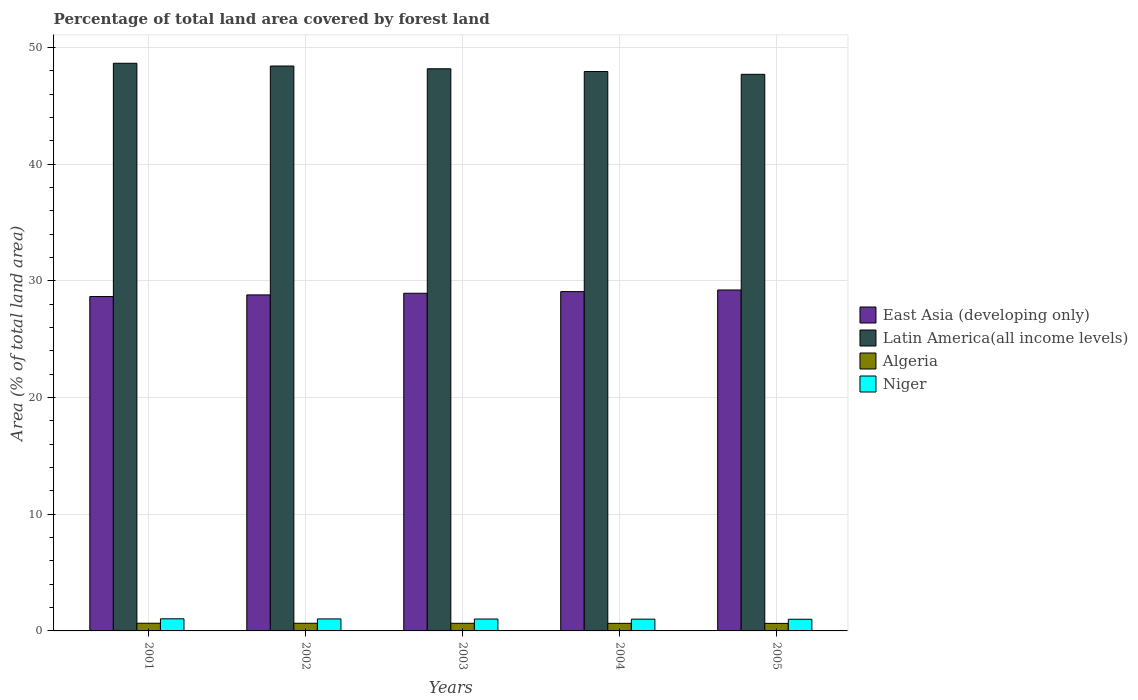How many different coloured bars are there?
Your response must be concise. 4. Are the number of bars per tick equal to the number of legend labels?
Offer a terse response. Yes. What is the label of the 1st group of bars from the left?
Make the answer very short. 2001. In how many cases, is the number of bars for a given year not equal to the number of legend labels?
Ensure brevity in your answer.  0. What is the percentage of forest land in East Asia (developing only) in 2001?
Ensure brevity in your answer.  28.65. Across all years, what is the maximum percentage of forest land in East Asia (developing only)?
Your answer should be very brief. 29.22. Across all years, what is the minimum percentage of forest land in Niger?
Offer a very short reply. 1. In which year was the percentage of forest land in Latin America(all income levels) minimum?
Provide a succinct answer. 2005. What is the total percentage of forest land in East Asia (developing only) in the graph?
Provide a succinct answer. 144.68. What is the difference between the percentage of forest land in Latin America(all income levels) in 2003 and that in 2004?
Your response must be concise. 0.24. What is the difference between the percentage of forest land in Latin America(all income levels) in 2005 and the percentage of forest land in East Asia (developing only) in 2004?
Your answer should be very brief. 18.62. What is the average percentage of forest land in Niger per year?
Give a very brief answer. 1.02. In the year 2004, what is the difference between the percentage of forest land in East Asia (developing only) and percentage of forest land in Algeria?
Keep it short and to the point. 28.43. In how many years, is the percentage of forest land in Niger greater than 10 %?
Offer a terse response. 0. What is the ratio of the percentage of forest land in Niger in 2001 to that in 2002?
Your response must be concise. 1.01. Is the percentage of forest land in Niger in 2001 less than that in 2003?
Offer a very short reply. No. Is the difference between the percentage of forest land in East Asia (developing only) in 2001 and 2004 greater than the difference between the percentage of forest land in Algeria in 2001 and 2004?
Your answer should be compact. No. What is the difference between the highest and the second highest percentage of forest land in Niger?
Keep it short and to the point. 0.01. What is the difference between the highest and the lowest percentage of forest land in Niger?
Provide a succinct answer. 0.04. What does the 1st bar from the left in 2004 represents?
Keep it short and to the point. East Asia (developing only). What does the 1st bar from the right in 2001 represents?
Provide a succinct answer. Niger. How many bars are there?
Make the answer very short. 20. How many years are there in the graph?
Give a very brief answer. 5. What is the difference between two consecutive major ticks on the Y-axis?
Ensure brevity in your answer.  10. Are the values on the major ticks of Y-axis written in scientific E-notation?
Your answer should be very brief. No. Does the graph contain any zero values?
Provide a short and direct response. No. Does the graph contain grids?
Make the answer very short. Yes. Where does the legend appear in the graph?
Your answer should be very brief. Center right. How many legend labels are there?
Your response must be concise. 4. What is the title of the graph?
Keep it short and to the point. Percentage of total land area covered by forest land. What is the label or title of the Y-axis?
Provide a short and direct response. Area (% of total land area). What is the Area (% of total land area) of East Asia (developing only) in 2001?
Provide a succinct answer. 28.65. What is the Area (% of total land area) in Latin America(all income levels) in 2001?
Your answer should be compact. 48.65. What is the Area (% of total land area) in Algeria in 2001?
Keep it short and to the point. 0.66. What is the Area (% of total land area) in Niger in 2001?
Your response must be concise. 1.04. What is the Area (% of total land area) in East Asia (developing only) in 2002?
Provide a succinct answer. 28.8. What is the Area (% of total land area) in Latin America(all income levels) in 2002?
Offer a terse response. 48.41. What is the Area (% of total land area) in Algeria in 2002?
Offer a terse response. 0.66. What is the Area (% of total land area) in Niger in 2002?
Ensure brevity in your answer.  1.03. What is the Area (% of total land area) in East Asia (developing only) in 2003?
Offer a very short reply. 28.94. What is the Area (% of total land area) in Latin America(all income levels) in 2003?
Give a very brief answer. 48.17. What is the Area (% of total land area) of Algeria in 2003?
Offer a very short reply. 0.65. What is the Area (% of total land area) of Niger in 2003?
Give a very brief answer. 1.02. What is the Area (% of total land area) of East Asia (developing only) in 2004?
Give a very brief answer. 29.08. What is the Area (% of total land area) of Latin America(all income levels) in 2004?
Your response must be concise. 47.94. What is the Area (% of total land area) in Algeria in 2004?
Provide a succinct answer. 0.65. What is the Area (% of total land area) of Niger in 2004?
Your answer should be very brief. 1.01. What is the Area (% of total land area) in East Asia (developing only) in 2005?
Make the answer very short. 29.22. What is the Area (% of total land area) in Latin America(all income levels) in 2005?
Ensure brevity in your answer.  47.7. What is the Area (% of total land area) in Algeria in 2005?
Offer a very short reply. 0.64. What is the Area (% of total land area) of Niger in 2005?
Offer a very short reply. 1. Across all years, what is the maximum Area (% of total land area) of East Asia (developing only)?
Provide a succinct answer. 29.22. Across all years, what is the maximum Area (% of total land area) of Latin America(all income levels)?
Your response must be concise. 48.65. Across all years, what is the maximum Area (% of total land area) in Algeria?
Offer a terse response. 0.66. Across all years, what is the maximum Area (% of total land area) in Niger?
Ensure brevity in your answer.  1.04. Across all years, what is the minimum Area (% of total land area) in East Asia (developing only)?
Give a very brief answer. 28.65. Across all years, what is the minimum Area (% of total land area) of Latin America(all income levels)?
Keep it short and to the point. 47.7. Across all years, what is the minimum Area (% of total land area) of Algeria?
Provide a short and direct response. 0.64. Across all years, what is the minimum Area (% of total land area) of Niger?
Ensure brevity in your answer.  1. What is the total Area (% of total land area) of East Asia (developing only) in the graph?
Your answer should be compact. 144.68. What is the total Area (% of total land area) of Latin America(all income levels) in the graph?
Ensure brevity in your answer.  240.86. What is the total Area (% of total land area) in Algeria in the graph?
Keep it short and to the point. 3.26. What is the total Area (% of total land area) of Niger in the graph?
Keep it short and to the point. 5.1. What is the difference between the Area (% of total land area) in East Asia (developing only) in 2001 and that in 2002?
Ensure brevity in your answer.  -0.14. What is the difference between the Area (% of total land area) of Latin America(all income levels) in 2001 and that in 2002?
Make the answer very short. 0.23. What is the difference between the Area (% of total land area) of Algeria in 2001 and that in 2002?
Your answer should be very brief. 0. What is the difference between the Area (% of total land area) in Niger in 2001 and that in 2002?
Your response must be concise. 0.01. What is the difference between the Area (% of total land area) of East Asia (developing only) in 2001 and that in 2003?
Give a very brief answer. -0.28. What is the difference between the Area (% of total land area) of Latin America(all income levels) in 2001 and that in 2003?
Ensure brevity in your answer.  0.47. What is the difference between the Area (% of total land area) of Algeria in 2001 and that in 2003?
Offer a terse response. 0.01. What is the difference between the Area (% of total land area) of Niger in 2001 and that in 2003?
Make the answer very short. 0.02. What is the difference between the Area (% of total land area) in East Asia (developing only) in 2001 and that in 2004?
Ensure brevity in your answer.  -0.42. What is the difference between the Area (% of total land area) of Latin America(all income levels) in 2001 and that in 2004?
Offer a terse response. 0.71. What is the difference between the Area (% of total land area) in Algeria in 2001 and that in 2004?
Keep it short and to the point. 0.01. What is the difference between the Area (% of total land area) in Niger in 2001 and that in 2004?
Provide a succinct answer. 0.03. What is the difference between the Area (% of total land area) in East Asia (developing only) in 2001 and that in 2005?
Your answer should be compact. -0.56. What is the difference between the Area (% of total land area) in Latin America(all income levels) in 2001 and that in 2005?
Make the answer very short. 0.95. What is the difference between the Area (% of total land area) in Algeria in 2001 and that in 2005?
Provide a short and direct response. 0.01. What is the difference between the Area (% of total land area) in Niger in 2001 and that in 2005?
Keep it short and to the point. 0.04. What is the difference between the Area (% of total land area) of East Asia (developing only) in 2002 and that in 2003?
Your answer should be compact. -0.14. What is the difference between the Area (% of total land area) in Latin America(all income levels) in 2002 and that in 2003?
Make the answer very short. 0.24. What is the difference between the Area (% of total land area) of Algeria in 2002 and that in 2003?
Provide a succinct answer. 0. What is the difference between the Area (% of total land area) of Niger in 2002 and that in 2003?
Provide a short and direct response. 0.01. What is the difference between the Area (% of total land area) of East Asia (developing only) in 2002 and that in 2004?
Ensure brevity in your answer.  -0.28. What is the difference between the Area (% of total land area) in Latin America(all income levels) in 2002 and that in 2004?
Your answer should be compact. 0.47. What is the difference between the Area (% of total land area) in Algeria in 2002 and that in 2004?
Provide a short and direct response. 0.01. What is the difference between the Area (% of total land area) of Niger in 2002 and that in 2004?
Keep it short and to the point. 0.02. What is the difference between the Area (% of total land area) in East Asia (developing only) in 2002 and that in 2005?
Your answer should be very brief. -0.42. What is the difference between the Area (% of total land area) of Latin America(all income levels) in 2002 and that in 2005?
Your response must be concise. 0.71. What is the difference between the Area (% of total land area) in Algeria in 2002 and that in 2005?
Give a very brief answer. 0.01. What is the difference between the Area (% of total land area) in Niger in 2002 and that in 2005?
Provide a succinct answer. 0.03. What is the difference between the Area (% of total land area) in East Asia (developing only) in 2003 and that in 2004?
Make the answer very short. -0.14. What is the difference between the Area (% of total land area) of Latin America(all income levels) in 2003 and that in 2004?
Ensure brevity in your answer.  0.24. What is the difference between the Area (% of total land area) of Algeria in 2003 and that in 2004?
Your answer should be compact. 0. What is the difference between the Area (% of total land area) of Niger in 2003 and that in 2004?
Ensure brevity in your answer.  0.01. What is the difference between the Area (% of total land area) of East Asia (developing only) in 2003 and that in 2005?
Make the answer very short. -0.28. What is the difference between the Area (% of total land area) of Latin America(all income levels) in 2003 and that in 2005?
Give a very brief answer. 0.47. What is the difference between the Area (% of total land area) in Algeria in 2003 and that in 2005?
Your answer should be compact. 0.01. What is the difference between the Area (% of total land area) in Niger in 2003 and that in 2005?
Your answer should be very brief. 0.02. What is the difference between the Area (% of total land area) of East Asia (developing only) in 2004 and that in 2005?
Offer a very short reply. -0.14. What is the difference between the Area (% of total land area) of Latin America(all income levels) in 2004 and that in 2005?
Your answer should be very brief. 0.24. What is the difference between the Area (% of total land area) in Algeria in 2004 and that in 2005?
Provide a short and direct response. 0. What is the difference between the Area (% of total land area) in Niger in 2004 and that in 2005?
Your response must be concise. 0.01. What is the difference between the Area (% of total land area) in East Asia (developing only) in 2001 and the Area (% of total land area) in Latin America(all income levels) in 2002?
Ensure brevity in your answer.  -19.76. What is the difference between the Area (% of total land area) of East Asia (developing only) in 2001 and the Area (% of total land area) of Algeria in 2002?
Your answer should be compact. 28. What is the difference between the Area (% of total land area) of East Asia (developing only) in 2001 and the Area (% of total land area) of Niger in 2002?
Give a very brief answer. 27.63. What is the difference between the Area (% of total land area) in Latin America(all income levels) in 2001 and the Area (% of total land area) in Algeria in 2002?
Keep it short and to the point. 47.99. What is the difference between the Area (% of total land area) of Latin America(all income levels) in 2001 and the Area (% of total land area) of Niger in 2002?
Provide a short and direct response. 47.62. What is the difference between the Area (% of total land area) of Algeria in 2001 and the Area (% of total land area) of Niger in 2002?
Your answer should be very brief. -0.37. What is the difference between the Area (% of total land area) of East Asia (developing only) in 2001 and the Area (% of total land area) of Latin America(all income levels) in 2003?
Ensure brevity in your answer.  -19.52. What is the difference between the Area (% of total land area) of East Asia (developing only) in 2001 and the Area (% of total land area) of Algeria in 2003?
Offer a very short reply. 28. What is the difference between the Area (% of total land area) in East Asia (developing only) in 2001 and the Area (% of total land area) in Niger in 2003?
Keep it short and to the point. 27.64. What is the difference between the Area (% of total land area) of Latin America(all income levels) in 2001 and the Area (% of total land area) of Algeria in 2003?
Your response must be concise. 47.99. What is the difference between the Area (% of total land area) of Latin America(all income levels) in 2001 and the Area (% of total land area) of Niger in 2003?
Keep it short and to the point. 47.63. What is the difference between the Area (% of total land area) of Algeria in 2001 and the Area (% of total land area) of Niger in 2003?
Your response must be concise. -0.36. What is the difference between the Area (% of total land area) of East Asia (developing only) in 2001 and the Area (% of total land area) of Latin America(all income levels) in 2004?
Your answer should be compact. -19.28. What is the difference between the Area (% of total land area) in East Asia (developing only) in 2001 and the Area (% of total land area) in Algeria in 2004?
Your response must be concise. 28.01. What is the difference between the Area (% of total land area) in East Asia (developing only) in 2001 and the Area (% of total land area) in Niger in 2004?
Offer a terse response. 27.65. What is the difference between the Area (% of total land area) of Latin America(all income levels) in 2001 and the Area (% of total land area) of Algeria in 2004?
Your answer should be compact. 48. What is the difference between the Area (% of total land area) of Latin America(all income levels) in 2001 and the Area (% of total land area) of Niger in 2004?
Your answer should be compact. 47.64. What is the difference between the Area (% of total land area) of Algeria in 2001 and the Area (% of total land area) of Niger in 2004?
Your answer should be compact. -0.35. What is the difference between the Area (% of total land area) of East Asia (developing only) in 2001 and the Area (% of total land area) of Latin America(all income levels) in 2005?
Your response must be concise. -19.04. What is the difference between the Area (% of total land area) of East Asia (developing only) in 2001 and the Area (% of total land area) of Algeria in 2005?
Offer a terse response. 28.01. What is the difference between the Area (% of total land area) of East Asia (developing only) in 2001 and the Area (% of total land area) of Niger in 2005?
Ensure brevity in your answer.  27.66. What is the difference between the Area (% of total land area) in Latin America(all income levels) in 2001 and the Area (% of total land area) in Algeria in 2005?
Make the answer very short. 48. What is the difference between the Area (% of total land area) of Latin America(all income levels) in 2001 and the Area (% of total land area) of Niger in 2005?
Offer a terse response. 47.65. What is the difference between the Area (% of total land area) of Algeria in 2001 and the Area (% of total land area) of Niger in 2005?
Provide a succinct answer. -0.34. What is the difference between the Area (% of total land area) in East Asia (developing only) in 2002 and the Area (% of total land area) in Latin America(all income levels) in 2003?
Keep it short and to the point. -19.38. What is the difference between the Area (% of total land area) of East Asia (developing only) in 2002 and the Area (% of total land area) of Algeria in 2003?
Your response must be concise. 28.14. What is the difference between the Area (% of total land area) of East Asia (developing only) in 2002 and the Area (% of total land area) of Niger in 2003?
Your answer should be compact. 27.78. What is the difference between the Area (% of total land area) in Latin America(all income levels) in 2002 and the Area (% of total land area) in Algeria in 2003?
Ensure brevity in your answer.  47.76. What is the difference between the Area (% of total land area) of Latin America(all income levels) in 2002 and the Area (% of total land area) of Niger in 2003?
Offer a terse response. 47.39. What is the difference between the Area (% of total land area) of Algeria in 2002 and the Area (% of total land area) of Niger in 2003?
Keep it short and to the point. -0.36. What is the difference between the Area (% of total land area) in East Asia (developing only) in 2002 and the Area (% of total land area) in Latin America(all income levels) in 2004?
Give a very brief answer. -19.14. What is the difference between the Area (% of total land area) in East Asia (developing only) in 2002 and the Area (% of total land area) in Algeria in 2004?
Your response must be concise. 28.15. What is the difference between the Area (% of total land area) of East Asia (developing only) in 2002 and the Area (% of total land area) of Niger in 2004?
Offer a terse response. 27.79. What is the difference between the Area (% of total land area) of Latin America(all income levels) in 2002 and the Area (% of total land area) of Algeria in 2004?
Your answer should be compact. 47.76. What is the difference between the Area (% of total land area) in Latin America(all income levels) in 2002 and the Area (% of total land area) in Niger in 2004?
Provide a succinct answer. 47.4. What is the difference between the Area (% of total land area) in Algeria in 2002 and the Area (% of total land area) in Niger in 2004?
Your answer should be compact. -0.35. What is the difference between the Area (% of total land area) of East Asia (developing only) in 2002 and the Area (% of total land area) of Latin America(all income levels) in 2005?
Your response must be concise. -18.9. What is the difference between the Area (% of total land area) in East Asia (developing only) in 2002 and the Area (% of total land area) in Algeria in 2005?
Make the answer very short. 28.15. What is the difference between the Area (% of total land area) of East Asia (developing only) in 2002 and the Area (% of total land area) of Niger in 2005?
Your answer should be compact. 27.8. What is the difference between the Area (% of total land area) of Latin America(all income levels) in 2002 and the Area (% of total land area) of Algeria in 2005?
Keep it short and to the point. 47.77. What is the difference between the Area (% of total land area) of Latin America(all income levels) in 2002 and the Area (% of total land area) of Niger in 2005?
Ensure brevity in your answer.  47.41. What is the difference between the Area (% of total land area) in Algeria in 2002 and the Area (% of total land area) in Niger in 2005?
Your answer should be very brief. -0.34. What is the difference between the Area (% of total land area) in East Asia (developing only) in 2003 and the Area (% of total land area) in Latin America(all income levels) in 2004?
Provide a short and direct response. -19. What is the difference between the Area (% of total land area) in East Asia (developing only) in 2003 and the Area (% of total land area) in Algeria in 2004?
Make the answer very short. 28.29. What is the difference between the Area (% of total land area) in East Asia (developing only) in 2003 and the Area (% of total land area) in Niger in 2004?
Make the answer very short. 27.93. What is the difference between the Area (% of total land area) in Latin America(all income levels) in 2003 and the Area (% of total land area) in Algeria in 2004?
Ensure brevity in your answer.  47.52. What is the difference between the Area (% of total land area) in Latin America(all income levels) in 2003 and the Area (% of total land area) in Niger in 2004?
Make the answer very short. 47.16. What is the difference between the Area (% of total land area) of Algeria in 2003 and the Area (% of total land area) of Niger in 2004?
Keep it short and to the point. -0.36. What is the difference between the Area (% of total land area) in East Asia (developing only) in 2003 and the Area (% of total land area) in Latin America(all income levels) in 2005?
Ensure brevity in your answer.  -18.76. What is the difference between the Area (% of total land area) in East Asia (developing only) in 2003 and the Area (% of total land area) in Algeria in 2005?
Make the answer very short. 28.29. What is the difference between the Area (% of total land area) of East Asia (developing only) in 2003 and the Area (% of total land area) of Niger in 2005?
Your answer should be compact. 27.94. What is the difference between the Area (% of total land area) of Latin America(all income levels) in 2003 and the Area (% of total land area) of Algeria in 2005?
Offer a terse response. 47.53. What is the difference between the Area (% of total land area) of Latin America(all income levels) in 2003 and the Area (% of total land area) of Niger in 2005?
Your answer should be compact. 47.17. What is the difference between the Area (% of total land area) of Algeria in 2003 and the Area (% of total land area) of Niger in 2005?
Your response must be concise. -0.35. What is the difference between the Area (% of total land area) in East Asia (developing only) in 2004 and the Area (% of total land area) in Latin America(all income levels) in 2005?
Offer a very short reply. -18.62. What is the difference between the Area (% of total land area) in East Asia (developing only) in 2004 and the Area (% of total land area) in Algeria in 2005?
Provide a short and direct response. 28.43. What is the difference between the Area (% of total land area) of East Asia (developing only) in 2004 and the Area (% of total land area) of Niger in 2005?
Your answer should be compact. 28.08. What is the difference between the Area (% of total land area) in Latin America(all income levels) in 2004 and the Area (% of total land area) in Algeria in 2005?
Provide a succinct answer. 47.29. What is the difference between the Area (% of total land area) in Latin America(all income levels) in 2004 and the Area (% of total land area) in Niger in 2005?
Offer a terse response. 46.94. What is the difference between the Area (% of total land area) in Algeria in 2004 and the Area (% of total land area) in Niger in 2005?
Give a very brief answer. -0.35. What is the average Area (% of total land area) in East Asia (developing only) per year?
Give a very brief answer. 28.94. What is the average Area (% of total land area) of Latin America(all income levels) per year?
Provide a succinct answer. 48.17. What is the average Area (% of total land area) of Algeria per year?
Make the answer very short. 0.65. In the year 2001, what is the difference between the Area (% of total land area) of East Asia (developing only) and Area (% of total land area) of Latin America(all income levels)?
Offer a terse response. -19.99. In the year 2001, what is the difference between the Area (% of total land area) of East Asia (developing only) and Area (% of total land area) of Algeria?
Keep it short and to the point. 28. In the year 2001, what is the difference between the Area (% of total land area) of East Asia (developing only) and Area (% of total land area) of Niger?
Make the answer very short. 27.62. In the year 2001, what is the difference between the Area (% of total land area) of Latin America(all income levels) and Area (% of total land area) of Algeria?
Ensure brevity in your answer.  47.99. In the year 2001, what is the difference between the Area (% of total land area) of Latin America(all income levels) and Area (% of total land area) of Niger?
Provide a short and direct response. 47.61. In the year 2001, what is the difference between the Area (% of total land area) of Algeria and Area (% of total land area) of Niger?
Keep it short and to the point. -0.38. In the year 2002, what is the difference between the Area (% of total land area) of East Asia (developing only) and Area (% of total land area) of Latin America(all income levels)?
Your response must be concise. -19.61. In the year 2002, what is the difference between the Area (% of total land area) of East Asia (developing only) and Area (% of total land area) of Algeria?
Provide a succinct answer. 28.14. In the year 2002, what is the difference between the Area (% of total land area) of East Asia (developing only) and Area (% of total land area) of Niger?
Your response must be concise. 27.77. In the year 2002, what is the difference between the Area (% of total land area) in Latin America(all income levels) and Area (% of total land area) in Algeria?
Your response must be concise. 47.75. In the year 2002, what is the difference between the Area (% of total land area) of Latin America(all income levels) and Area (% of total land area) of Niger?
Your response must be concise. 47.38. In the year 2002, what is the difference between the Area (% of total land area) of Algeria and Area (% of total land area) of Niger?
Your answer should be compact. -0.37. In the year 2003, what is the difference between the Area (% of total land area) in East Asia (developing only) and Area (% of total land area) in Latin America(all income levels)?
Offer a very short reply. -19.24. In the year 2003, what is the difference between the Area (% of total land area) of East Asia (developing only) and Area (% of total land area) of Algeria?
Offer a terse response. 28.28. In the year 2003, what is the difference between the Area (% of total land area) of East Asia (developing only) and Area (% of total land area) of Niger?
Give a very brief answer. 27.92. In the year 2003, what is the difference between the Area (% of total land area) of Latin America(all income levels) and Area (% of total land area) of Algeria?
Your response must be concise. 47.52. In the year 2003, what is the difference between the Area (% of total land area) in Latin America(all income levels) and Area (% of total land area) in Niger?
Offer a terse response. 47.15. In the year 2003, what is the difference between the Area (% of total land area) of Algeria and Area (% of total land area) of Niger?
Give a very brief answer. -0.37. In the year 2004, what is the difference between the Area (% of total land area) of East Asia (developing only) and Area (% of total land area) of Latin America(all income levels)?
Give a very brief answer. -18.86. In the year 2004, what is the difference between the Area (% of total land area) of East Asia (developing only) and Area (% of total land area) of Algeria?
Ensure brevity in your answer.  28.43. In the year 2004, what is the difference between the Area (% of total land area) in East Asia (developing only) and Area (% of total land area) in Niger?
Keep it short and to the point. 28.07. In the year 2004, what is the difference between the Area (% of total land area) of Latin America(all income levels) and Area (% of total land area) of Algeria?
Make the answer very short. 47.29. In the year 2004, what is the difference between the Area (% of total land area) of Latin America(all income levels) and Area (% of total land area) of Niger?
Offer a terse response. 46.93. In the year 2004, what is the difference between the Area (% of total land area) in Algeria and Area (% of total land area) in Niger?
Your response must be concise. -0.36. In the year 2005, what is the difference between the Area (% of total land area) in East Asia (developing only) and Area (% of total land area) in Latin America(all income levels)?
Your answer should be very brief. -18.48. In the year 2005, what is the difference between the Area (% of total land area) of East Asia (developing only) and Area (% of total land area) of Algeria?
Ensure brevity in your answer.  28.57. In the year 2005, what is the difference between the Area (% of total land area) in East Asia (developing only) and Area (% of total land area) in Niger?
Keep it short and to the point. 28.22. In the year 2005, what is the difference between the Area (% of total land area) of Latin America(all income levels) and Area (% of total land area) of Algeria?
Provide a succinct answer. 47.05. In the year 2005, what is the difference between the Area (% of total land area) of Latin America(all income levels) and Area (% of total land area) of Niger?
Offer a terse response. 46.7. In the year 2005, what is the difference between the Area (% of total land area) of Algeria and Area (% of total land area) of Niger?
Your answer should be very brief. -0.35. What is the ratio of the Area (% of total land area) of East Asia (developing only) in 2001 to that in 2002?
Your answer should be very brief. 1. What is the ratio of the Area (% of total land area) of Niger in 2001 to that in 2002?
Your answer should be very brief. 1.01. What is the ratio of the Area (% of total land area) in East Asia (developing only) in 2001 to that in 2003?
Your response must be concise. 0.99. What is the ratio of the Area (% of total land area) of Latin America(all income levels) in 2001 to that in 2003?
Offer a very short reply. 1.01. What is the ratio of the Area (% of total land area) of Algeria in 2001 to that in 2003?
Give a very brief answer. 1.01. What is the ratio of the Area (% of total land area) of Niger in 2001 to that in 2003?
Make the answer very short. 1.02. What is the ratio of the Area (% of total land area) in East Asia (developing only) in 2001 to that in 2004?
Make the answer very short. 0.99. What is the ratio of the Area (% of total land area) of Latin America(all income levels) in 2001 to that in 2004?
Offer a terse response. 1.01. What is the ratio of the Area (% of total land area) of Algeria in 2001 to that in 2004?
Offer a terse response. 1.02. What is the ratio of the Area (% of total land area) of Niger in 2001 to that in 2004?
Offer a terse response. 1.03. What is the ratio of the Area (% of total land area) of East Asia (developing only) in 2001 to that in 2005?
Your answer should be compact. 0.98. What is the ratio of the Area (% of total land area) of Latin America(all income levels) in 2001 to that in 2005?
Make the answer very short. 1.02. What is the ratio of the Area (% of total land area) of Algeria in 2001 to that in 2005?
Ensure brevity in your answer.  1.02. What is the ratio of the Area (% of total land area) of Niger in 2001 to that in 2005?
Your answer should be very brief. 1.04. What is the ratio of the Area (% of total land area) of Latin America(all income levels) in 2002 to that in 2003?
Make the answer very short. 1. What is the ratio of the Area (% of total land area) in Niger in 2002 to that in 2003?
Your answer should be compact. 1.01. What is the ratio of the Area (% of total land area) in East Asia (developing only) in 2002 to that in 2004?
Provide a succinct answer. 0.99. What is the ratio of the Area (% of total land area) of Latin America(all income levels) in 2002 to that in 2004?
Provide a succinct answer. 1.01. What is the ratio of the Area (% of total land area) in Algeria in 2002 to that in 2004?
Provide a short and direct response. 1.01. What is the ratio of the Area (% of total land area) in Niger in 2002 to that in 2004?
Ensure brevity in your answer.  1.02. What is the ratio of the Area (% of total land area) of East Asia (developing only) in 2002 to that in 2005?
Your response must be concise. 0.99. What is the ratio of the Area (% of total land area) of Latin America(all income levels) in 2002 to that in 2005?
Provide a succinct answer. 1.01. What is the ratio of the Area (% of total land area) of Algeria in 2002 to that in 2005?
Your answer should be very brief. 1.02. What is the ratio of the Area (% of total land area) in Niger in 2002 to that in 2005?
Ensure brevity in your answer.  1.03. What is the ratio of the Area (% of total land area) in Algeria in 2003 to that in 2004?
Your answer should be very brief. 1.01. What is the ratio of the Area (% of total land area) of Niger in 2003 to that in 2004?
Give a very brief answer. 1.01. What is the ratio of the Area (% of total land area) of Algeria in 2003 to that in 2005?
Make the answer very short. 1.01. What is the ratio of the Area (% of total land area) of Niger in 2003 to that in 2005?
Your answer should be very brief. 1.02. What is the ratio of the Area (% of total land area) in Algeria in 2004 to that in 2005?
Ensure brevity in your answer.  1.01. What is the ratio of the Area (% of total land area) in Niger in 2004 to that in 2005?
Give a very brief answer. 1.01. What is the difference between the highest and the second highest Area (% of total land area) in East Asia (developing only)?
Provide a short and direct response. 0.14. What is the difference between the highest and the second highest Area (% of total land area) in Latin America(all income levels)?
Provide a succinct answer. 0.23. What is the difference between the highest and the second highest Area (% of total land area) of Algeria?
Offer a terse response. 0. What is the difference between the highest and the second highest Area (% of total land area) of Niger?
Your answer should be compact. 0.01. What is the difference between the highest and the lowest Area (% of total land area) in East Asia (developing only)?
Keep it short and to the point. 0.56. What is the difference between the highest and the lowest Area (% of total land area) of Algeria?
Provide a succinct answer. 0.01. What is the difference between the highest and the lowest Area (% of total land area) in Niger?
Your answer should be compact. 0.04. 